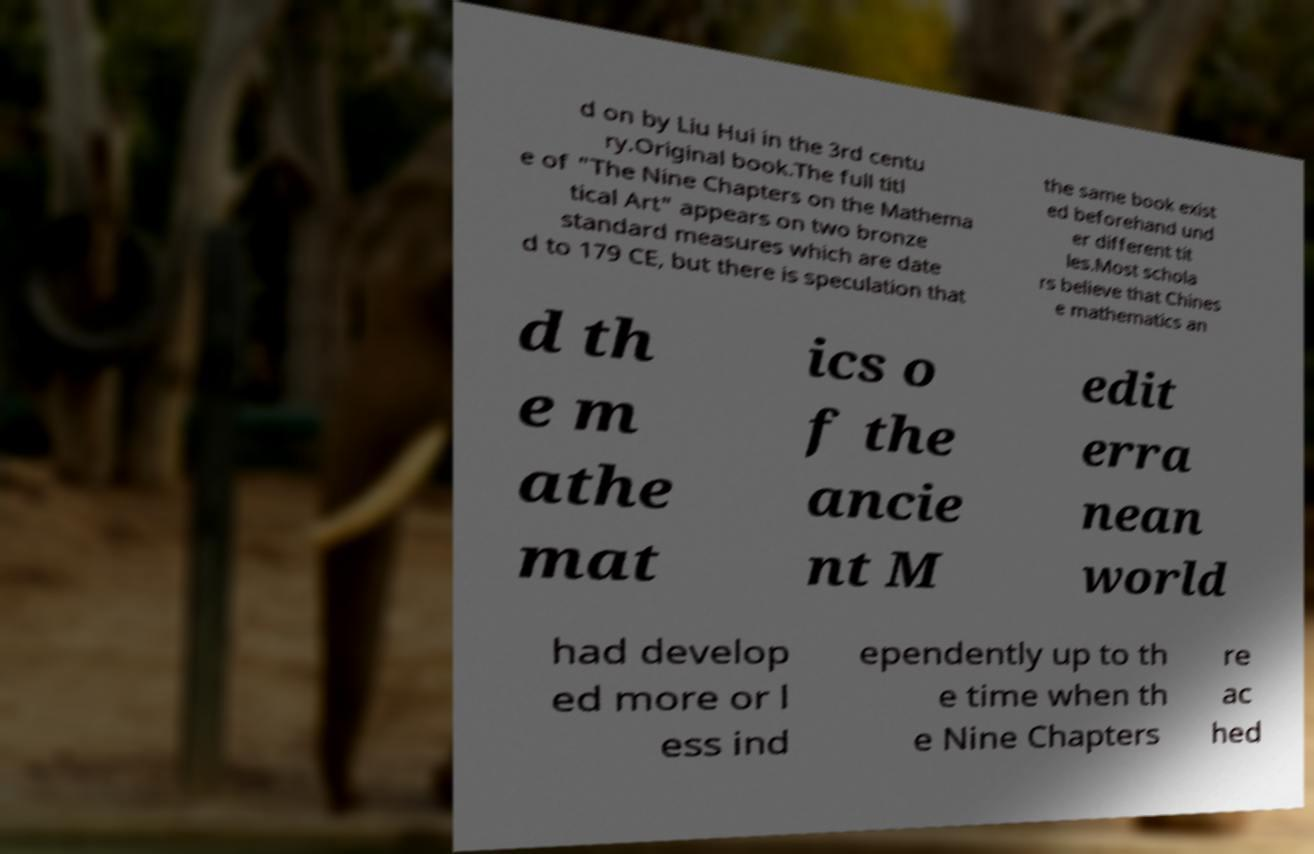Could you assist in decoding the text presented in this image and type it out clearly? d on by Liu Hui in the 3rd centu ry.Original book.The full titl e of "The Nine Chapters on the Mathema tical Art" appears on two bronze standard measures which are date d to 179 CE, but there is speculation that the same book exist ed beforehand und er different tit les.Most schola rs believe that Chines e mathematics an d th e m athe mat ics o f the ancie nt M edit erra nean world had develop ed more or l ess ind ependently up to th e time when th e Nine Chapters re ac hed 